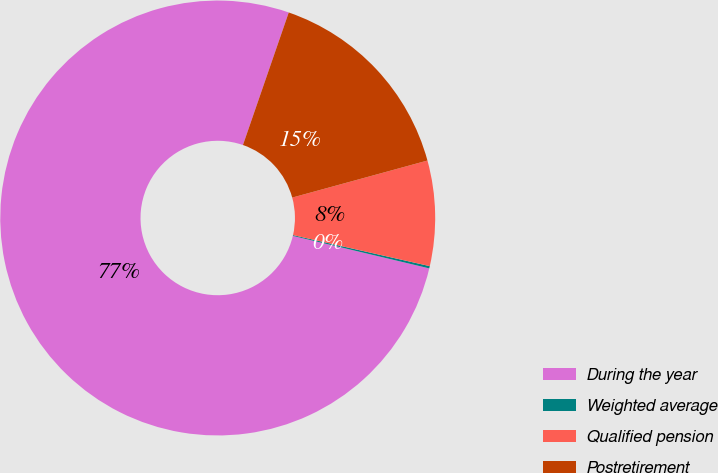<chart> <loc_0><loc_0><loc_500><loc_500><pie_chart><fcel>During the year<fcel>Weighted average<fcel>Qualified pension<fcel>Postretirement<nl><fcel>76.58%<fcel>0.17%<fcel>7.81%<fcel>15.45%<nl></chart> 